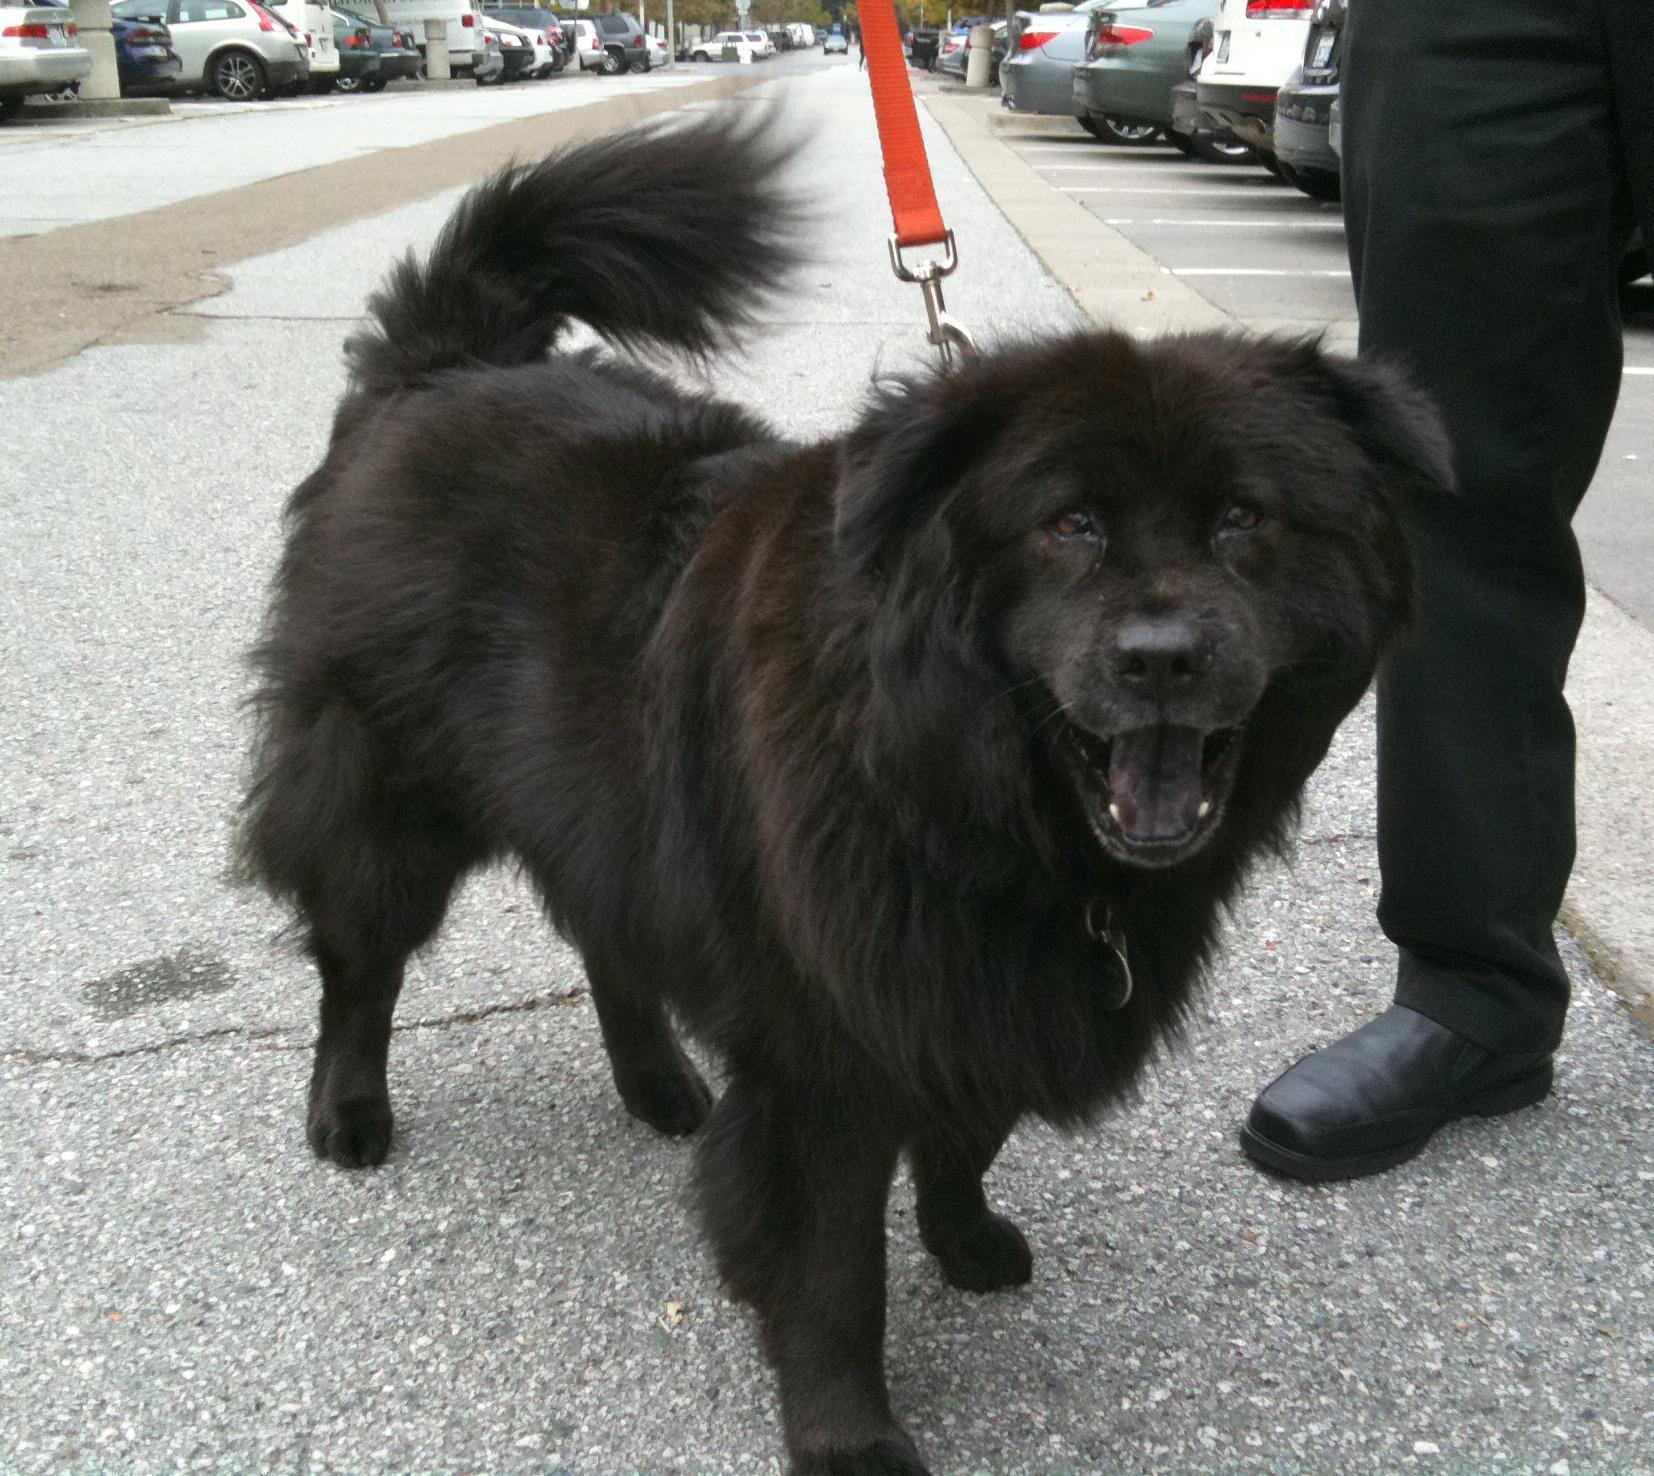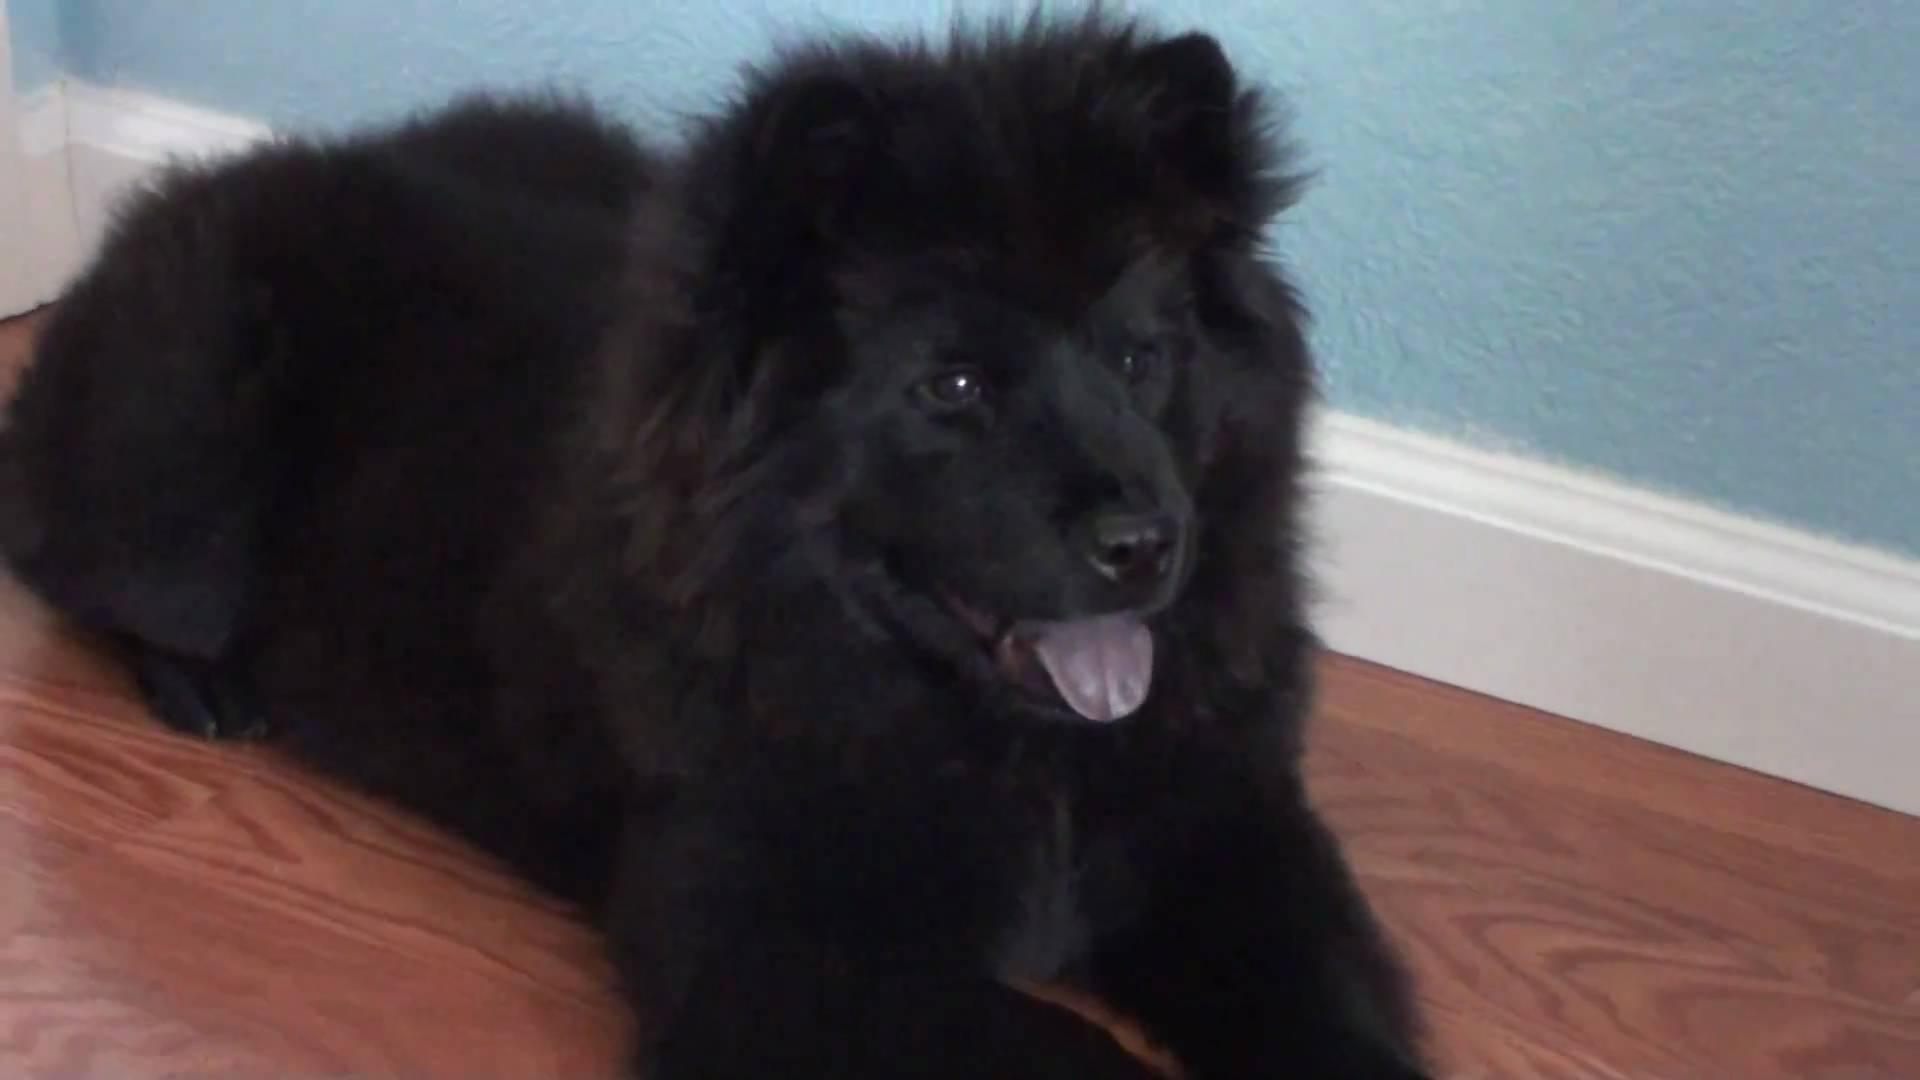The first image is the image on the left, the second image is the image on the right. For the images shown, is this caption "The dog in one of the images is lying down." true? Answer yes or no. Yes. 